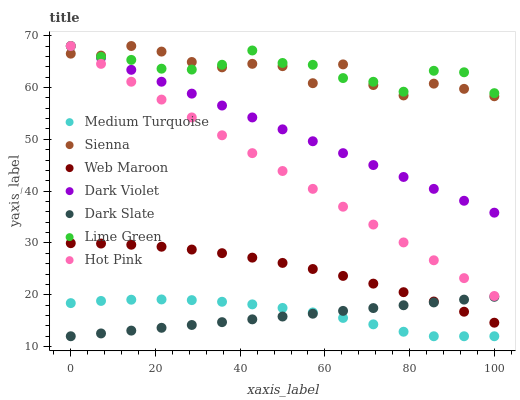Does Dark Slate have the minimum area under the curve?
Answer yes or no. Yes. Does Lime Green have the maximum area under the curve?
Answer yes or no. Yes. Does Web Maroon have the minimum area under the curve?
Answer yes or no. No. Does Web Maroon have the maximum area under the curve?
Answer yes or no. No. Is Dark Slate the smoothest?
Answer yes or no. Yes. Is Sienna the roughest?
Answer yes or no. Yes. Is Web Maroon the smoothest?
Answer yes or no. No. Is Web Maroon the roughest?
Answer yes or no. No. Does Dark Slate have the lowest value?
Answer yes or no. Yes. Does Web Maroon have the lowest value?
Answer yes or no. No. Does Lime Green have the highest value?
Answer yes or no. Yes. Does Web Maroon have the highest value?
Answer yes or no. No. Is Dark Slate less than Dark Violet?
Answer yes or no. Yes. Is Web Maroon greater than Medium Turquoise?
Answer yes or no. Yes. Does Sienna intersect Hot Pink?
Answer yes or no. Yes. Is Sienna less than Hot Pink?
Answer yes or no. No. Is Sienna greater than Hot Pink?
Answer yes or no. No. Does Dark Slate intersect Dark Violet?
Answer yes or no. No. 